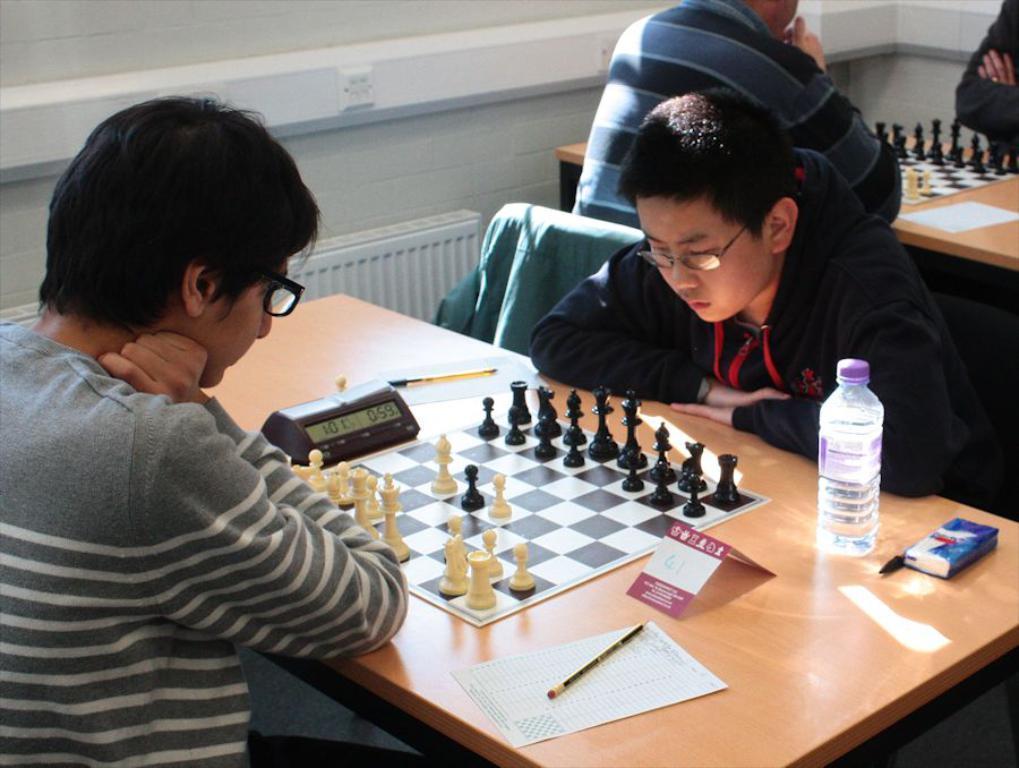In one or two sentences, can you explain what this image depicts? In this image we can see tables and few people sitting on chairs. Two person are wearing specs. On the tables there are chess boards with coins, timer, papers, pens, pencils and packet. In the back there is a wall. 